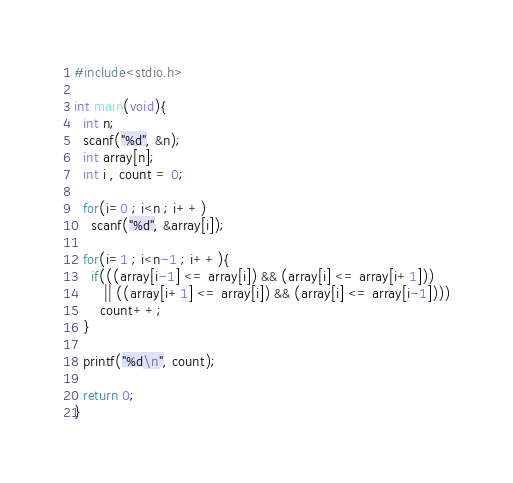Convert code to text. <code><loc_0><loc_0><loc_500><loc_500><_C_>#include<stdio.h>

int main(void){
  int n;
  scanf("%d", &n);
  int array[n];
  int i , count = 0;

  for(i=0 ; i<n ; i++)
    scanf("%d", &array[i]);

  for(i=1 ; i<n-1 ; i++){
    if(((array[i-1] <= array[i]) && (array[i] <= array[i+1])) 
       || ((array[i+1] <= array[i]) && (array[i] <= array[i-1])))
      count++;
  }

  printf("%d\n", count);

  return 0;
}
</code> 